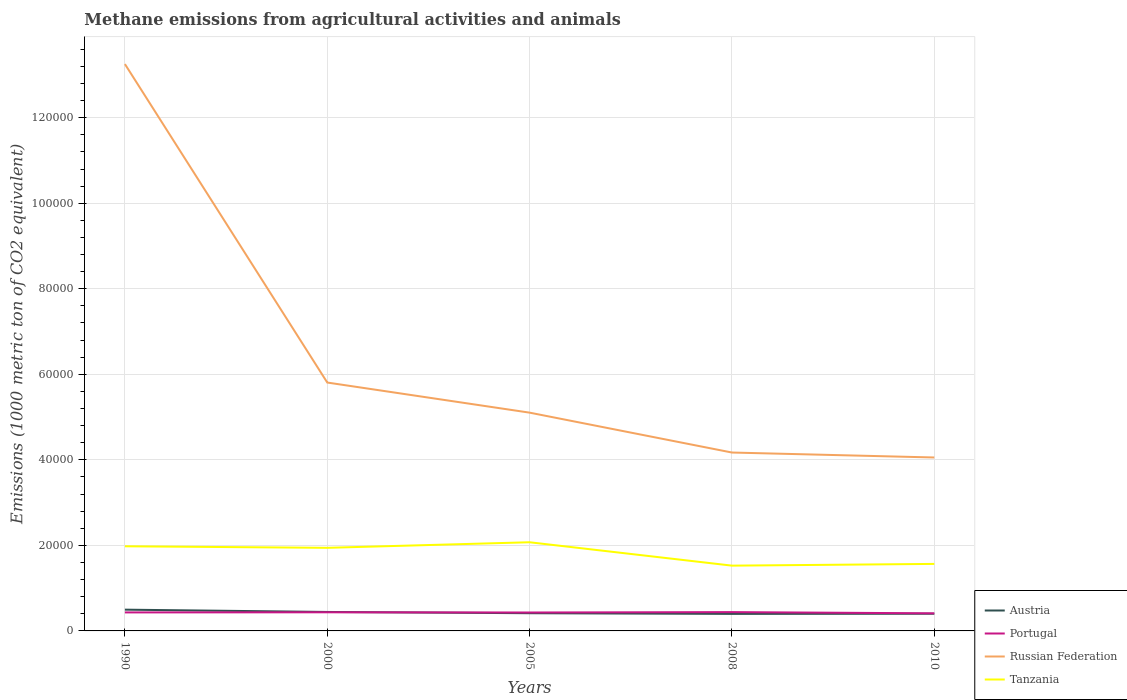How many different coloured lines are there?
Offer a terse response. 4. Does the line corresponding to Portugal intersect with the line corresponding to Austria?
Make the answer very short. Yes. Is the number of lines equal to the number of legend labels?
Provide a short and direct response. Yes. Across all years, what is the maximum amount of methane emitted in Russian Federation?
Provide a succinct answer. 4.06e+04. What is the total amount of methane emitted in Tanzania in the graph?
Provide a short and direct response. 5468. What is the difference between the highest and the second highest amount of methane emitted in Tanzania?
Your answer should be very brief. 5468. Is the amount of methane emitted in Austria strictly greater than the amount of methane emitted in Tanzania over the years?
Your answer should be very brief. Yes. What is the difference between two consecutive major ticks on the Y-axis?
Your answer should be compact. 2.00e+04. Are the values on the major ticks of Y-axis written in scientific E-notation?
Keep it short and to the point. No. Where does the legend appear in the graph?
Your answer should be compact. Bottom right. How many legend labels are there?
Keep it short and to the point. 4. How are the legend labels stacked?
Keep it short and to the point. Vertical. What is the title of the graph?
Make the answer very short. Methane emissions from agricultural activities and animals. Does "Tajikistan" appear as one of the legend labels in the graph?
Provide a succinct answer. No. What is the label or title of the Y-axis?
Your response must be concise. Emissions (1000 metric ton of CO2 equivalent). What is the Emissions (1000 metric ton of CO2 equivalent) of Austria in 1990?
Offer a terse response. 4973.8. What is the Emissions (1000 metric ton of CO2 equivalent) of Portugal in 1990?
Your response must be concise. 4324.1. What is the Emissions (1000 metric ton of CO2 equivalent) in Russian Federation in 1990?
Ensure brevity in your answer.  1.33e+05. What is the Emissions (1000 metric ton of CO2 equivalent) of Tanzania in 1990?
Your answer should be compact. 1.98e+04. What is the Emissions (1000 metric ton of CO2 equivalent) of Austria in 2000?
Offer a very short reply. 4433.9. What is the Emissions (1000 metric ton of CO2 equivalent) of Portugal in 2000?
Keep it short and to the point. 4355.4. What is the Emissions (1000 metric ton of CO2 equivalent) in Russian Federation in 2000?
Provide a succinct answer. 5.81e+04. What is the Emissions (1000 metric ton of CO2 equivalent) in Tanzania in 2000?
Provide a short and direct response. 1.94e+04. What is the Emissions (1000 metric ton of CO2 equivalent) in Austria in 2005?
Offer a very short reply. 4138.3. What is the Emissions (1000 metric ton of CO2 equivalent) in Portugal in 2005?
Ensure brevity in your answer.  4307.2. What is the Emissions (1000 metric ton of CO2 equivalent) of Russian Federation in 2005?
Make the answer very short. 5.10e+04. What is the Emissions (1000 metric ton of CO2 equivalent) in Tanzania in 2005?
Your answer should be very brief. 2.07e+04. What is the Emissions (1000 metric ton of CO2 equivalent) of Austria in 2008?
Provide a short and direct response. 3982.8. What is the Emissions (1000 metric ton of CO2 equivalent) of Portugal in 2008?
Provide a short and direct response. 4397.6. What is the Emissions (1000 metric ton of CO2 equivalent) of Russian Federation in 2008?
Keep it short and to the point. 4.17e+04. What is the Emissions (1000 metric ton of CO2 equivalent) of Tanzania in 2008?
Offer a terse response. 1.53e+04. What is the Emissions (1000 metric ton of CO2 equivalent) in Austria in 2010?
Provide a succinct answer. 4018.8. What is the Emissions (1000 metric ton of CO2 equivalent) in Portugal in 2010?
Offer a very short reply. 4113.1. What is the Emissions (1000 metric ton of CO2 equivalent) of Russian Federation in 2010?
Ensure brevity in your answer.  4.06e+04. What is the Emissions (1000 metric ton of CO2 equivalent) of Tanzania in 2010?
Make the answer very short. 1.57e+04. Across all years, what is the maximum Emissions (1000 metric ton of CO2 equivalent) in Austria?
Keep it short and to the point. 4973.8. Across all years, what is the maximum Emissions (1000 metric ton of CO2 equivalent) in Portugal?
Offer a terse response. 4397.6. Across all years, what is the maximum Emissions (1000 metric ton of CO2 equivalent) in Russian Federation?
Offer a terse response. 1.33e+05. Across all years, what is the maximum Emissions (1000 metric ton of CO2 equivalent) in Tanzania?
Provide a succinct answer. 2.07e+04. Across all years, what is the minimum Emissions (1000 metric ton of CO2 equivalent) of Austria?
Make the answer very short. 3982.8. Across all years, what is the minimum Emissions (1000 metric ton of CO2 equivalent) of Portugal?
Your response must be concise. 4113.1. Across all years, what is the minimum Emissions (1000 metric ton of CO2 equivalent) of Russian Federation?
Provide a succinct answer. 4.06e+04. Across all years, what is the minimum Emissions (1000 metric ton of CO2 equivalent) of Tanzania?
Your response must be concise. 1.53e+04. What is the total Emissions (1000 metric ton of CO2 equivalent) in Austria in the graph?
Offer a terse response. 2.15e+04. What is the total Emissions (1000 metric ton of CO2 equivalent) of Portugal in the graph?
Offer a very short reply. 2.15e+04. What is the total Emissions (1000 metric ton of CO2 equivalent) of Russian Federation in the graph?
Ensure brevity in your answer.  3.24e+05. What is the total Emissions (1000 metric ton of CO2 equivalent) in Tanzania in the graph?
Offer a very short reply. 9.09e+04. What is the difference between the Emissions (1000 metric ton of CO2 equivalent) in Austria in 1990 and that in 2000?
Your answer should be compact. 539.9. What is the difference between the Emissions (1000 metric ton of CO2 equivalent) of Portugal in 1990 and that in 2000?
Offer a very short reply. -31.3. What is the difference between the Emissions (1000 metric ton of CO2 equivalent) of Russian Federation in 1990 and that in 2000?
Make the answer very short. 7.45e+04. What is the difference between the Emissions (1000 metric ton of CO2 equivalent) in Tanzania in 1990 and that in 2000?
Keep it short and to the point. 358.8. What is the difference between the Emissions (1000 metric ton of CO2 equivalent) of Austria in 1990 and that in 2005?
Keep it short and to the point. 835.5. What is the difference between the Emissions (1000 metric ton of CO2 equivalent) in Portugal in 1990 and that in 2005?
Your response must be concise. 16.9. What is the difference between the Emissions (1000 metric ton of CO2 equivalent) of Russian Federation in 1990 and that in 2005?
Your answer should be compact. 8.15e+04. What is the difference between the Emissions (1000 metric ton of CO2 equivalent) of Tanzania in 1990 and that in 2005?
Make the answer very short. -942.8. What is the difference between the Emissions (1000 metric ton of CO2 equivalent) of Austria in 1990 and that in 2008?
Make the answer very short. 991. What is the difference between the Emissions (1000 metric ton of CO2 equivalent) of Portugal in 1990 and that in 2008?
Offer a very short reply. -73.5. What is the difference between the Emissions (1000 metric ton of CO2 equivalent) of Russian Federation in 1990 and that in 2008?
Make the answer very short. 9.08e+04. What is the difference between the Emissions (1000 metric ton of CO2 equivalent) in Tanzania in 1990 and that in 2008?
Make the answer very short. 4525.2. What is the difference between the Emissions (1000 metric ton of CO2 equivalent) in Austria in 1990 and that in 2010?
Your answer should be very brief. 955. What is the difference between the Emissions (1000 metric ton of CO2 equivalent) in Portugal in 1990 and that in 2010?
Keep it short and to the point. 211. What is the difference between the Emissions (1000 metric ton of CO2 equivalent) of Russian Federation in 1990 and that in 2010?
Ensure brevity in your answer.  9.20e+04. What is the difference between the Emissions (1000 metric ton of CO2 equivalent) in Tanzania in 1990 and that in 2010?
Provide a short and direct response. 4118.2. What is the difference between the Emissions (1000 metric ton of CO2 equivalent) in Austria in 2000 and that in 2005?
Offer a very short reply. 295.6. What is the difference between the Emissions (1000 metric ton of CO2 equivalent) in Portugal in 2000 and that in 2005?
Provide a succinct answer. 48.2. What is the difference between the Emissions (1000 metric ton of CO2 equivalent) of Russian Federation in 2000 and that in 2005?
Your answer should be compact. 7040. What is the difference between the Emissions (1000 metric ton of CO2 equivalent) of Tanzania in 2000 and that in 2005?
Offer a very short reply. -1301.6. What is the difference between the Emissions (1000 metric ton of CO2 equivalent) of Austria in 2000 and that in 2008?
Your answer should be very brief. 451.1. What is the difference between the Emissions (1000 metric ton of CO2 equivalent) of Portugal in 2000 and that in 2008?
Your answer should be compact. -42.2. What is the difference between the Emissions (1000 metric ton of CO2 equivalent) of Russian Federation in 2000 and that in 2008?
Ensure brevity in your answer.  1.64e+04. What is the difference between the Emissions (1000 metric ton of CO2 equivalent) of Tanzania in 2000 and that in 2008?
Give a very brief answer. 4166.4. What is the difference between the Emissions (1000 metric ton of CO2 equivalent) of Austria in 2000 and that in 2010?
Keep it short and to the point. 415.1. What is the difference between the Emissions (1000 metric ton of CO2 equivalent) in Portugal in 2000 and that in 2010?
Provide a short and direct response. 242.3. What is the difference between the Emissions (1000 metric ton of CO2 equivalent) of Russian Federation in 2000 and that in 2010?
Ensure brevity in your answer.  1.75e+04. What is the difference between the Emissions (1000 metric ton of CO2 equivalent) of Tanzania in 2000 and that in 2010?
Ensure brevity in your answer.  3759.4. What is the difference between the Emissions (1000 metric ton of CO2 equivalent) of Austria in 2005 and that in 2008?
Provide a short and direct response. 155.5. What is the difference between the Emissions (1000 metric ton of CO2 equivalent) in Portugal in 2005 and that in 2008?
Offer a terse response. -90.4. What is the difference between the Emissions (1000 metric ton of CO2 equivalent) in Russian Federation in 2005 and that in 2008?
Ensure brevity in your answer.  9324.6. What is the difference between the Emissions (1000 metric ton of CO2 equivalent) of Tanzania in 2005 and that in 2008?
Offer a very short reply. 5468. What is the difference between the Emissions (1000 metric ton of CO2 equivalent) of Austria in 2005 and that in 2010?
Make the answer very short. 119.5. What is the difference between the Emissions (1000 metric ton of CO2 equivalent) of Portugal in 2005 and that in 2010?
Offer a very short reply. 194.1. What is the difference between the Emissions (1000 metric ton of CO2 equivalent) in Russian Federation in 2005 and that in 2010?
Your answer should be very brief. 1.05e+04. What is the difference between the Emissions (1000 metric ton of CO2 equivalent) of Tanzania in 2005 and that in 2010?
Keep it short and to the point. 5061. What is the difference between the Emissions (1000 metric ton of CO2 equivalent) in Austria in 2008 and that in 2010?
Your answer should be very brief. -36. What is the difference between the Emissions (1000 metric ton of CO2 equivalent) of Portugal in 2008 and that in 2010?
Provide a short and direct response. 284.5. What is the difference between the Emissions (1000 metric ton of CO2 equivalent) of Russian Federation in 2008 and that in 2010?
Ensure brevity in your answer.  1158.2. What is the difference between the Emissions (1000 metric ton of CO2 equivalent) in Tanzania in 2008 and that in 2010?
Make the answer very short. -407. What is the difference between the Emissions (1000 metric ton of CO2 equivalent) in Austria in 1990 and the Emissions (1000 metric ton of CO2 equivalent) in Portugal in 2000?
Provide a succinct answer. 618.4. What is the difference between the Emissions (1000 metric ton of CO2 equivalent) of Austria in 1990 and the Emissions (1000 metric ton of CO2 equivalent) of Russian Federation in 2000?
Ensure brevity in your answer.  -5.31e+04. What is the difference between the Emissions (1000 metric ton of CO2 equivalent) in Austria in 1990 and the Emissions (1000 metric ton of CO2 equivalent) in Tanzania in 2000?
Your answer should be very brief. -1.45e+04. What is the difference between the Emissions (1000 metric ton of CO2 equivalent) of Portugal in 1990 and the Emissions (1000 metric ton of CO2 equivalent) of Russian Federation in 2000?
Make the answer very short. -5.38e+04. What is the difference between the Emissions (1000 metric ton of CO2 equivalent) in Portugal in 1990 and the Emissions (1000 metric ton of CO2 equivalent) in Tanzania in 2000?
Make the answer very short. -1.51e+04. What is the difference between the Emissions (1000 metric ton of CO2 equivalent) of Russian Federation in 1990 and the Emissions (1000 metric ton of CO2 equivalent) of Tanzania in 2000?
Your response must be concise. 1.13e+05. What is the difference between the Emissions (1000 metric ton of CO2 equivalent) in Austria in 1990 and the Emissions (1000 metric ton of CO2 equivalent) in Portugal in 2005?
Your response must be concise. 666.6. What is the difference between the Emissions (1000 metric ton of CO2 equivalent) in Austria in 1990 and the Emissions (1000 metric ton of CO2 equivalent) in Russian Federation in 2005?
Make the answer very short. -4.61e+04. What is the difference between the Emissions (1000 metric ton of CO2 equivalent) in Austria in 1990 and the Emissions (1000 metric ton of CO2 equivalent) in Tanzania in 2005?
Ensure brevity in your answer.  -1.58e+04. What is the difference between the Emissions (1000 metric ton of CO2 equivalent) in Portugal in 1990 and the Emissions (1000 metric ton of CO2 equivalent) in Russian Federation in 2005?
Offer a terse response. -4.67e+04. What is the difference between the Emissions (1000 metric ton of CO2 equivalent) of Portugal in 1990 and the Emissions (1000 metric ton of CO2 equivalent) of Tanzania in 2005?
Ensure brevity in your answer.  -1.64e+04. What is the difference between the Emissions (1000 metric ton of CO2 equivalent) of Russian Federation in 1990 and the Emissions (1000 metric ton of CO2 equivalent) of Tanzania in 2005?
Keep it short and to the point. 1.12e+05. What is the difference between the Emissions (1000 metric ton of CO2 equivalent) in Austria in 1990 and the Emissions (1000 metric ton of CO2 equivalent) in Portugal in 2008?
Offer a very short reply. 576.2. What is the difference between the Emissions (1000 metric ton of CO2 equivalent) in Austria in 1990 and the Emissions (1000 metric ton of CO2 equivalent) in Russian Federation in 2008?
Offer a very short reply. -3.67e+04. What is the difference between the Emissions (1000 metric ton of CO2 equivalent) of Austria in 1990 and the Emissions (1000 metric ton of CO2 equivalent) of Tanzania in 2008?
Provide a short and direct response. -1.03e+04. What is the difference between the Emissions (1000 metric ton of CO2 equivalent) in Portugal in 1990 and the Emissions (1000 metric ton of CO2 equivalent) in Russian Federation in 2008?
Keep it short and to the point. -3.74e+04. What is the difference between the Emissions (1000 metric ton of CO2 equivalent) of Portugal in 1990 and the Emissions (1000 metric ton of CO2 equivalent) of Tanzania in 2008?
Your answer should be compact. -1.09e+04. What is the difference between the Emissions (1000 metric ton of CO2 equivalent) of Russian Federation in 1990 and the Emissions (1000 metric ton of CO2 equivalent) of Tanzania in 2008?
Make the answer very short. 1.17e+05. What is the difference between the Emissions (1000 metric ton of CO2 equivalent) of Austria in 1990 and the Emissions (1000 metric ton of CO2 equivalent) of Portugal in 2010?
Keep it short and to the point. 860.7. What is the difference between the Emissions (1000 metric ton of CO2 equivalent) of Austria in 1990 and the Emissions (1000 metric ton of CO2 equivalent) of Russian Federation in 2010?
Ensure brevity in your answer.  -3.56e+04. What is the difference between the Emissions (1000 metric ton of CO2 equivalent) of Austria in 1990 and the Emissions (1000 metric ton of CO2 equivalent) of Tanzania in 2010?
Provide a short and direct response. -1.07e+04. What is the difference between the Emissions (1000 metric ton of CO2 equivalent) in Portugal in 1990 and the Emissions (1000 metric ton of CO2 equivalent) in Russian Federation in 2010?
Offer a terse response. -3.62e+04. What is the difference between the Emissions (1000 metric ton of CO2 equivalent) of Portugal in 1990 and the Emissions (1000 metric ton of CO2 equivalent) of Tanzania in 2010?
Provide a succinct answer. -1.13e+04. What is the difference between the Emissions (1000 metric ton of CO2 equivalent) in Russian Federation in 1990 and the Emissions (1000 metric ton of CO2 equivalent) in Tanzania in 2010?
Offer a very short reply. 1.17e+05. What is the difference between the Emissions (1000 metric ton of CO2 equivalent) of Austria in 2000 and the Emissions (1000 metric ton of CO2 equivalent) of Portugal in 2005?
Ensure brevity in your answer.  126.7. What is the difference between the Emissions (1000 metric ton of CO2 equivalent) of Austria in 2000 and the Emissions (1000 metric ton of CO2 equivalent) of Russian Federation in 2005?
Give a very brief answer. -4.66e+04. What is the difference between the Emissions (1000 metric ton of CO2 equivalent) of Austria in 2000 and the Emissions (1000 metric ton of CO2 equivalent) of Tanzania in 2005?
Offer a very short reply. -1.63e+04. What is the difference between the Emissions (1000 metric ton of CO2 equivalent) of Portugal in 2000 and the Emissions (1000 metric ton of CO2 equivalent) of Russian Federation in 2005?
Provide a succinct answer. -4.67e+04. What is the difference between the Emissions (1000 metric ton of CO2 equivalent) of Portugal in 2000 and the Emissions (1000 metric ton of CO2 equivalent) of Tanzania in 2005?
Your answer should be very brief. -1.64e+04. What is the difference between the Emissions (1000 metric ton of CO2 equivalent) of Russian Federation in 2000 and the Emissions (1000 metric ton of CO2 equivalent) of Tanzania in 2005?
Give a very brief answer. 3.73e+04. What is the difference between the Emissions (1000 metric ton of CO2 equivalent) in Austria in 2000 and the Emissions (1000 metric ton of CO2 equivalent) in Portugal in 2008?
Offer a terse response. 36.3. What is the difference between the Emissions (1000 metric ton of CO2 equivalent) of Austria in 2000 and the Emissions (1000 metric ton of CO2 equivalent) of Russian Federation in 2008?
Your answer should be compact. -3.73e+04. What is the difference between the Emissions (1000 metric ton of CO2 equivalent) in Austria in 2000 and the Emissions (1000 metric ton of CO2 equivalent) in Tanzania in 2008?
Give a very brief answer. -1.08e+04. What is the difference between the Emissions (1000 metric ton of CO2 equivalent) of Portugal in 2000 and the Emissions (1000 metric ton of CO2 equivalent) of Russian Federation in 2008?
Give a very brief answer. -3.74e+04. What is the difference between the Emissions (1000 metric ton of CO2 equivalent) in Portugal in 2000 and the Emissions (1000 metric ton of CO2 equivalent) in Tanzania in 2008?
Offer a terse response. -1.09e+04. What is the difference between the Emissions (1000 metric ton of CO2 equivalent) in Russian Federation in 2000 and the Emissions (1000 metric ton of CO2 equivalent) in Tanzania in 2008?
Ensure brevity in your answer.  4.28e+04. What is the difference between the Emissions (1000 metric ton of CO2 equivalent) of Austria in 2000 and the Emissions (1000 metric ton of CO2 equivalent) of Portugal in 2010?
Offer a very short reply. 320.8. What is the difference between the Emissions (1000 metric ton of CO2 equivalent) of Austria in 2000 and the Emissions (1000 metric ton of CO2 equivalent) of Russian Federation in 2010?
Give a very brief answer. -3.61e+04. What is the difference between the Emissions (1000 metric ton of CO2 equivalent) in Austria in 2000 and the Emissions (1000 metric ton of CO2 equivalent) in Tanzania in 2010?
Ensure brevity in your answer.  -1.12e+04. What is the difference between the Emissions (1000 metric ton of CO2 equivalent) of Portugal in 2000 and the Emissions (1000 metric ton of CO2 equivalent) of Russian Federation in 2010?
Your response must be concise. -3.62e+04. What is the difference between the Emissions (1000 metric ton of CO2 equivalent) in Portugal in 2000 and the Emissions (1000 metric ton of CO2 equivalent) in Tanzania in 2010?
Offer a very short reply. -1.13e+04. What is the difference between the Emissions (1000 metric ton of CO2 equivalent) of Russian Federation in 2000 and the Emissions (1000 metric ton of CO2 equivalent) of Tanzania in 2010?
Provide a succinct answer. 4.24e+04. What is the difference between the Emissions (1000 metric ton of CO2 equivalent) in Austria in 2005 and the Emissions (1000 metric ton of CO2 equivalent) in Portugal in 2008?
Provide a short and direct response. -259.3. What is the difference between the Emissions (1000 metric ton of CO2 equivalent) in Austria in 2005 and the Emissions (1000 metric ton of CO2 equivalent) in Russian Federation in 2008?
Offer a very short reply. -3.76e+04. What is the difference between the Emissions (1000 metric ton of CO2 equivalent) of Austria in 2005 and the Emissions (1000 metric ton of CO2 equivalent) of Tanzania in 2008?
Provide a succinct answer. -1.11e+04. What is the difference between the Emissions (1000 metric ton of CO2 equivalent) in Portugal in 2005 and the Emissions (1000 metric ton of CO2 equivalent) in Russian Federation in 2008?
Your answer should be compact. -3.74e+04. What is the difference between the Emissions (1000 metric ton of CO2 equivalent) in Portugal in 2005 and the Emissions (1000 metric ton of CO2 equivalent) in Tanzania in 2008?
Your answer should be very brief. -1.10e+04. What is the difference between the Emissions (1000 metric ton of CO2 equivalent) of Russian Federation in 2005 and the Emissions (1000 metric ton of CO2 equivalent) of Tanzania in 2008?
Offer a terse response. 3.58e+04. What is the difference between the Emissions (1000 metric ton of CO2 equivalent) in Austria in 2005 and the Emissions (1000 metric ton of CO2 equivalent) in Portugal in 2010?
Offer a very short reply. 25.2. What is the difference between the Emissions (1000 metric ton of CO2 equivalent) of Austria in 2005 and the Emissions (1000 metric ton of CO2 equivalent) of Russian Federation in 2010?
Provide a short and direct response. -3.64e+04. What is the difference between the Emissions (1000 metric ton of CO2 equivalent) in Austria in 2005 and the Emissions (1000 metric ton of CO2 equivalent) in Tanzania in 2010?
Offer a terse response. -1.15e+04. What is the difference between the Emissions (1000 metric ton of CO2 equivalent) of Portugal in 2005 and the Emissions (1000 metric ton of CO2 equivalent) of Russian Federation in 2010?
Offer a terse response. -3.62e+04. What is the difference between the Emissions (1000 metric ton of CO2 equivalent) of Portugal in 2005 and the Emissions (1000 metric ton of CO2 equivalent) of Tanzania in 2010?
Ensure brevity in your answer.  -1.14e+04. What is the difference between the Emissions (1000 metric ton of CO2 equivalent) in Russian Federation in 2005 and the Emissions (1000 metric ton of CO2 equivalent) in Tanzania in 2010?
Your answer should be compact. 3.54e+04. What is the difference between the Emissions (1000 metric ton of CO2 equivalent) of Austria in 2008 and the Emissions (1000 metric ton of CO2 equivalent) of Portugal in 2010?
Ensure brevity in your answer.  -130.3. What is the difference between the Emissions (1000 metric ton of CO2 equivalent) of Austria in 2008 and the Emissions (1000 metric ton of CO2 equivalent) of Russian Federation in 2010?
Your answer should be very brief. -3.66e+04. What is the difference between the Emissions (1000 metric ton of CO2 equivalent) in Austria in 2008 and the Emissions (1000 metric ton of CO2 equivalent) in Tanzania in 2010?
Offer a terse response. -1.17e+04. What is the difference between the Emissions (1000 metric ton of CO2 equivalent) of Portugal in 2008 and the Emissions (1000 metric ton of CO2 equivalent) of Russian Federation in 2010?
Your answer should be compact. -3.62e+04. What is the difference between the Emissions (1000 metric ton of CO2 equivalent) in Portugal in 2008 and the Emissions (1000 metric ton of CO2 equivalent) in Tanzania in 2010?
Provide a succinct answer. -1.13e+04. What is the difference between the Emissions (1000 metric ton of CO2 equivalent) in Russian Federation in 2008 and the Emissions (1000 metric ton of CO2 equivalent) in Tanzania in 2010?
Keep it short and to the point. 2.60e+04. What is the average Emissions (1000 metric ton of CO2 equivalent) in Austria per year?
Keep it short and to the point. 4309.52. What is the average Emissions (1000 metric ton of CO2 equivalent) in Portugal per year?
Your response must be concise. 4299.48. What is the average Emissions (1000 metric ton of CO2 equivalent) of Russian Federation per year?
Your answer should be very brief. 6.48e+04. What is the average Emissions (1000 metric ton of CO2 equivalent) of Tanzania per year?
Your answer should be very brief. 1.82e+04. In the year 1990, what is the difference between the Emissions (1000 metric ton of CO2 equivalent) of Austria and Emissions (1000 metric ton of CO2 equivalent) of Portugal?
Provide a succinct answer. 649.7. In the year 1990, what is the difference between the Emissions (1000 metric ton of CO2 equivalent) in Austria and Emissions (1000 metric ton of CO2 equivalent) in Russian Federation?
Your answer should be compact. -1.28e+05. In the year 1990, what is the difference between the Emissions (1000 metric ton of CO2 equivalent) of Austria and Emissions (1000 metric ton of CO2 equivalent) of Tanzania?
Provide a succinct answer. -1.48e+04. In the year 1990, what is the difference between the Emissions (1000 metric ton of CO2 equivalent) in Portugal and Emissions (1000 metric ton of CO2 equivalent) in Russian Federation?
Provide a short and direct response. -1.28e+05. In the year 1990, what is the difference between the Emissions (1000 metric ton of CO2 equivalent) of Portugal and Emissions (1000 metric ton of CO2 equivalent) of Tanzania?
Offer a terse response. -1.55e+04. In the year 1990, what is the difference between the Emissions (1000 metric ton of CO2 equivalent) of Russian Federation and Emissions (1000 metric ton of CO2 equivalent) of Tanzania?
Keep it short and to the point. 1.13e+05. In the year 2000, what is the difference between the Emissions (1000 metric ton of CO2 equivalent) of Austria and Emissions (1000 metric ton of CO2 equivalent) of Portugal?
Offer a terse response. 78.5. In the year 2000, what is the difference between the Emissions (1000 metric ton of CO2 equivalent) of Austria and Emissions (1000 metric ton of CO2 equivalent) of Russian Federation?
Make the answer very short. -5.36e+04. In the year 2000, what is the difference between the Emissions (1000 metric ton of CO2 equivalent) of Austria and Emissions (1000 metric ton of CO2 equivalent) of Tanzania?
Keep it short and to the point. -1.50e+04. In the year 2000, what is the difference between the Emissions (1000 metric ton of CO2 equivalent) of Portugal and Emissions (1000 metric ton of CO2 equivalent) of Russian Federation?
Your response must be concise. -5.37e+04. In the year 2000, what is the difference between the Emissions (1000 metric ton of CO2 equivalent) in Portugal and Emissions (1000 metric ton of CO2 equivalent) in Tanzania?
Give a very brief answer. -1.51e+04. In the year 2000, what is the difference between the Emissions (1000 metric ton of CO2 equivalent) of Russian Federation and Emissions (1000 metric ton of CO2 equivalent) of Tanzania?
Keep it short and to the point. 3.86e+04. In the year 2005, what is the difference between the Emissions (1000 metric ton of CO2 equivalent) of Austria and Emissions (1000 metric ton of CO2 equivalent) of Portugal?
Your answer should be very brief. -168.9. In the year 2005, what is the difference between the Emissions (1000 metric ton of CO2 equivalent) in Austria and Emissions (1000 metric ton of CO2 equivalent) in Russian Federation?
Keep it short and to the point. -4.69e+04. In the year 2005, what is the difference between the Emissions (1000 metric ton of CO2 equivalent) in Austria and Emissions (1000 metric ton of CO2 equivalent) in Tanzania?
Your response must be concise. -1.66e+04. In the year 2005, what is the difference between the Emissions (1000 metric ton of CO2 equivalent) in Portugal and Emissions (1000 metric ton of CO2 equivalent) in Russian Federation?
Offer a very short reply. -4.67e+04. In the year 2005, what is the difference between the Emissions (1000 metric ton of CO2 equivalent) of Portugal and Emissions (1000 metric ton of CO2 equivalent) of Tanzania?
Offer a very short reply. -1.64e+04. In the year 2005, what is the difference between the Emissions (1000 metric ton of CO2 equivalent) in Russian Federation and Emissions (1000 metric ton of CO2 equivalent) in Tanzania?
Give a very brief answer. 3.03e+04. In the year 2008, what is the difference between the Emissions (1000 metric ton of CO2 equivalent) of Austria and Emissions (1000 metric ton of CO2 equivalent) of Portugal?
Offer a very short reply. -414.8. In the year 2008, what is the difference between the Emissions (1000 metric ton of CO2 equivalent) in Austria and Emissions (1000 metric ton of CO2 equivalent) in Russian Federation?
Offer a terse response. -3.77e+04. In the year 2008, what is the difference between the Emissions (1000 metric ton of CO2 equivalent) in Austria and Emissions (1000 metric ton of CO2 equivalent) in Tanzania?
Ensure brevity in your answer.  -1.13e+04. In the year 2008, what is the difference between the Emissions (1000 metric ton of CO2 equivalent) of Portugal and Emissions (1000 metric ton of CO2 equivalent) of Russian Federation?
Make the answer very short. -3.73e+04. In the year 2008, what is the difference between the Emissions (1000 metric ton of CO2 equivalent) in Portugal and Emissions (1000 metric ton of CO2 equivalent) in Tanzania?
Your answer should be compact. -1.09e+04. In the year 2008, what is the difference between the Emissions (1000 metric ton of CO2 equivalent) of Russian Federation and Emissions (1000 metric ton of CO2 equivalent) of Tanzania?
Offer a very short reply. 2.64e+04. In the year 2010, what is the difference between the Emissions (1000 metric ton of CO2 equivalent) of Austria and Emissions (1000 metric ton of CO2 equivalent) of Portugal?
Provide a succinct answer. -94.3. In the year 2010, what is the difference between the Emissions (1000 metric ton of CO2 equivalent) of Austria and Emissions (1000 metric ton of CO2 equivalent) of Russian Federation?
Your answer should be compact. -3.65e+04. In the year 2010, what is the difference between the Emissions (1000 metric ton of CO2 equivalent) of Austria and Emissions (1000 metric ton of CO2 equivalent) of Tanzania?
Offer a terse response. -1.17e+04. In the year 2010, what is the difference between the Emissions (1000 metric ton of CO2 equivalent) of Portugal and Emissions (1000 metric ton of CO2 equivalent) of Russian Federation?
Provide a short and direct response. -3.64e+04. In the year 2010, what is the difference between the Emissions (1000 metric ton of CO2 equivalent) of Portugal and Emissions (1000 metric ton of CO2 equivalent) of Tanzania?
Your answer should be very brief. -1.16e+04. In the year 2010, what is the difference between the Emissions (1000 metric ton of CO2 equivalent) in Russian Federation and Emissions (1000 metric ton of CO2 equivalent) in Tanzania?
Keep it short and to the point. 2.49e+04. What is the ratio of the Emissions (1000 metric ton of CO2 equivalent) of Austria in 1990 to that in 2000?
Make the answer very short. 1.12. What is the ratio of the Emissions (1000 metric ton of CO2 equivalent) of Portugal in 1990 to that in 2000?
Your answer should be compact. 0.99. What is the ratio of the Emissions (1000 metric ton of CO2 equivalent) of Russian Federation in 1990 to that in 2000?
Offer a very short reply. 2.28. What is the ratio of the Emissions (1000 metric ton of CO2 equivalent) of Tanzania in 1990 to that in 2000?
Give a very brief answer. 1.02. What is the ratio of the Emissions (1000 metric ton of CO2 equivalent) of Austria in 1990 to that in 2005?
Your answer should be compact. 1.2. What is the ratio of the Emissions (1000 metric ton of CO2 equivalent) in Russian Federation in 1990 to that in 2005?
Offer a very short reply. 2.6. What is the ratio of the Emissions (1000 metric ton of CO2 equivalent) in Tanzania in 1990 to that in 2005?
Keep it short and to the point. 0.95. What is the ratio of the Emissions (1000 metric ton of CO2 equivalent) of Austria in 1990 to that in 2008?
Your answer should be compact. 1.25. What is the ratio of the Emissions (1000 metric ton of CO2 equivalent) in Portugal in 1990 to that in 2008?
Give a very brief answer. 0.98. What is the ratio of the Emissions (1000 metric ton of CO2 equivalent) of Russian Federation in 1990 to that in 2008?
Give a very brief answer. 3.18. What is the ratio of the Emissions (1000 metric ton of CO2 equivalent) in Tanzania in 1990 to that in 2008?
Offer a terse response. 1.3. What is the ratio of the Emissions (1000 metric ton of CO2 equivalent) in Austria in 1990 to that in 2010?
Your answer should be compact. 1.24. What is the ratio of the Emissions (1000 metric ton of CO2 equivalent) of Portugal in 1990 to that in 2010?
Your answer should be compact. 1.05. What is the ratio of the Emissions (1000 metric ton of CO2 equivalent) of Russian Federation in 1990 to that in 2010?
Your answer should be very brief. 3.27. What is the ratio of the Emissions (1000 metric ton of CO2 equivalent) in Tanzania in 1990 to that in 2010?
Your answer should be compact. 1.26. What is the ratio of the Emissions (1000 metric ton of CO2 equivalent) of Austria in 2000 to that in 2005?
Your answer should be very brief. 1.07. What is the ratio of the Emissions (1000 metric ton of CO2 equivalent) of Portugal in 2000 to that in 2005?
Your answer should be very brief. 1.01. What is the ratio of the Emissions (1000 metric ton of CO2 equivalent) of Russian Federation in 2000 to that in 2005?
Provide a succinct answer. 1.14. What is the ratio of the Emissions (1000 metric ton of CO2 equivalent) of Tanzania in 2000 to that in 2005?
Offer a terse response. 0.94. What is the ratio of the Emissions (1000 metric ton of CO2 equivalent) in Austria in 2000 to that in 2008?
Offer a terse response. 1.11. What is the ratio of the Emissions (1000 metric ton of CO2 equivalent) of Russian Federation in 2000 to that in 2008?
Your answer should be compact. 1.39. What is the ratio of the Emissions (1000 metric ton of CO2 equivalent) in Tanzania in 2000 to that in 2008?
Provide a short and direct response. 1.27. What is the ratio of the Emissions (1000 metric ton of CO2 equivalent) in Austria in 2000 to that in 2010?
Offer a terse response. 1.1. What is the ratio of the Emissions (1000 metric ton of CO2 equivalent) of Portugal in 2000 to that in 2010?
Provide a short and direct response. 1.06. What is the ratio of the Emissions (1000 metric ton of CO2 equivalent) in Russian Federation in 2000 to that in 2010?
Your answer should be very brief. 1.43. What is the ratio of the Emissions (1000 metric ton of CO2 equivalent) in Tanzania in 2000 to that in 2010?
Offer a very short reply. 1.24. What is the ratio of the Emissions (1000 metric ton of CO2 equivalent) of Austria in 2005 to that in 2008?
Offer a terse response. 1.04. What is the ratio of the Emissions (1000 metric ton of CO2 equivalent) of Portugal in 2005 to that in 2008?
Offer a very short reply. 0.98. What is the ratio of the Emissions (1000 metric ton of CO2 equivalent) in Russian Federation in 2005 to that in 2008?
Your response must be concise. 1.22. What is the ratio of the Emissions (1000 metric ton of CO2 equivalent) in Tanzania in 2005 to that in 2008?
Offer a very short reply. 1.36. What is the ratio of the Emissions (1000 metric ton of CO2 equivalent) of Austria in 2005 to that in 2010?
Provide a succinct answer. 1.03. What is the ratio of the Emissions (1000 metric ton of CO2 equivalent) of Portugal in 2005 to that in 2010?
Keep it short and to the point. 1.05. What is the ratio of the Emissions (1000 metric ton of CO2 equivalent) in Russian Federation in 2005 to that in 2010?
Ensure brevity in your answer.  1.26. What is the ratio of the Emissions (1000 metric ton of CO2 equivalent) of Tanzania in 2005 to that in 2010?
Offer a terse response. 1.32. What is the ratio of the Emissions (1000 metric ton of CO2 equivalent) in Austria in 2008 to that in 2010?
Ensure brevity in your answer.  0.99. What is the ratio of the Emissions (1000 metric ton of CO2 equivalent) in Portugal in 2008 to that in 2010?
Keep it short and to the point. 1.07. What is the ratio of the Emissions (1000 metric ton of CO2 equivalent) of Russian Federation in 2008 to that in 2010?
Keep it short and to the point. 1.03. What is the difference between the highest and the second highest Emissions (1000 metric ton of CO2 equivalent) of Austria?
Provide a short and direct response. 539.9. What is the difference between the highest and the second highest Emissions (1000 metric ton of CO2 equivalent) of Portugal?
Give a very brief answer. 42.2. What is the difference between the highest and the second highest Emissions (1000 metric ton of CO2 equivalent) in Russian Federation?
Provide a short and direct response. 7.45e+04. What is the difference between the highest and the second highest Emissions (1000 metric ton of CO2 equivalent) in Tanzania?
Ensure brevity in your answer.  942.8. What is the difference between the highest and the lowest Emissions (1000 metric ton of CO2 equivalent) in Austria?
Your answer should be compact. 991. What is the difference between the highest and the lowest Emissions (1000 metric ton of CO2 equivalent) of Portugal?
Make the answer very short. 284.5. What is the difference between the highest and the lowest Emissions (1000 metric ton of CO2 equivalent) in Russian Federation?
Make the answer very short. 9.20e+04. What is the difference between the highest and the lowest Emissions (1000 metric ton of CO2 equivalent) in Tanzania?
Provide a succinct answer. 5468. 